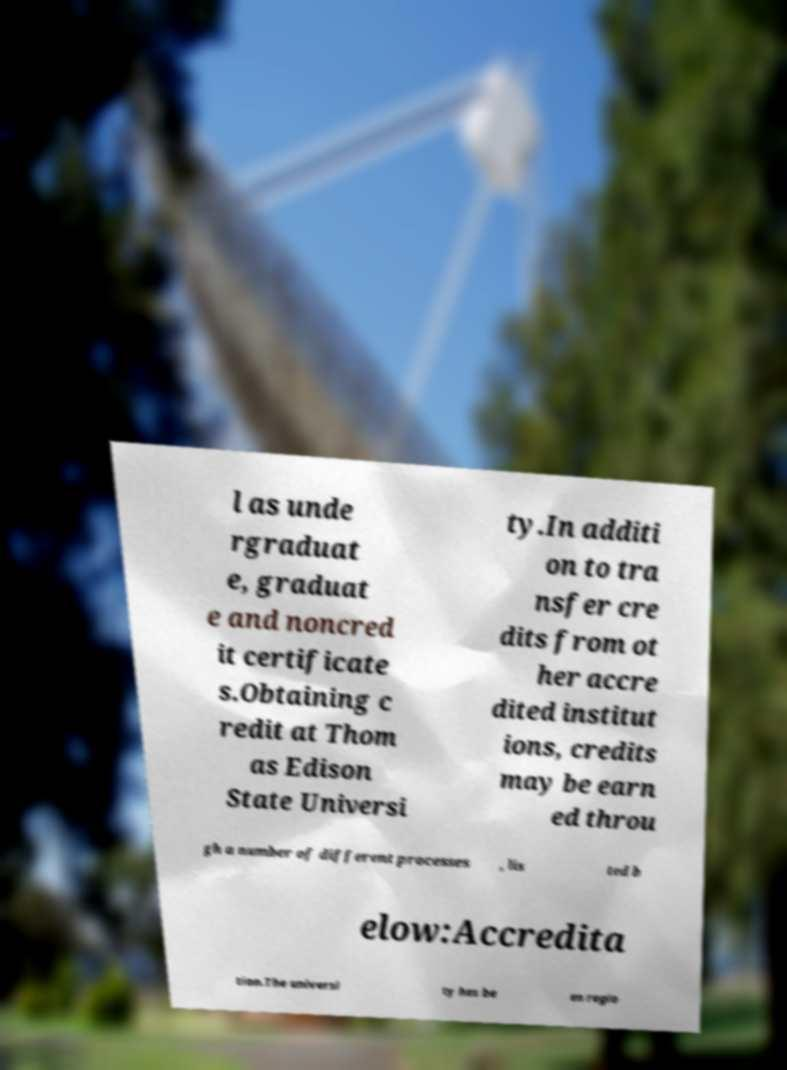For documentation purposes, I need the text within this image transcribed. Could you provide that? l as unde rgraduat e, graduat e and noncred it certificate s.Obtaining c redit at Thom as Edison State Universi ty.In additi on to tra nsfer cre dits from ot her accre dited institut ions, credits may be earn ed throu gh a number of different processes , lis ted b elow:Accredita tion.The universi ty has be en regio 